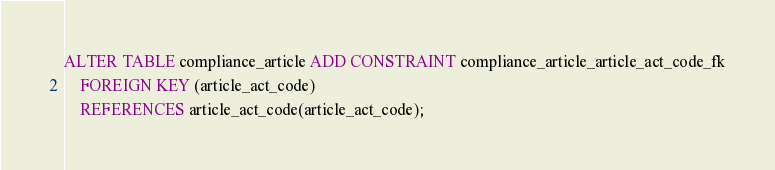Convert code to text. <code><loc_0><loc_0><loc_500><loc_500><_SQL_>ALTER TABLE compliance_article ADD CONSTRAINT compliance_article_article_act_code_fk
    FOREIGN KEY (article_act_code)
    REFERENCES article_act_code(article_act_code);</code> 